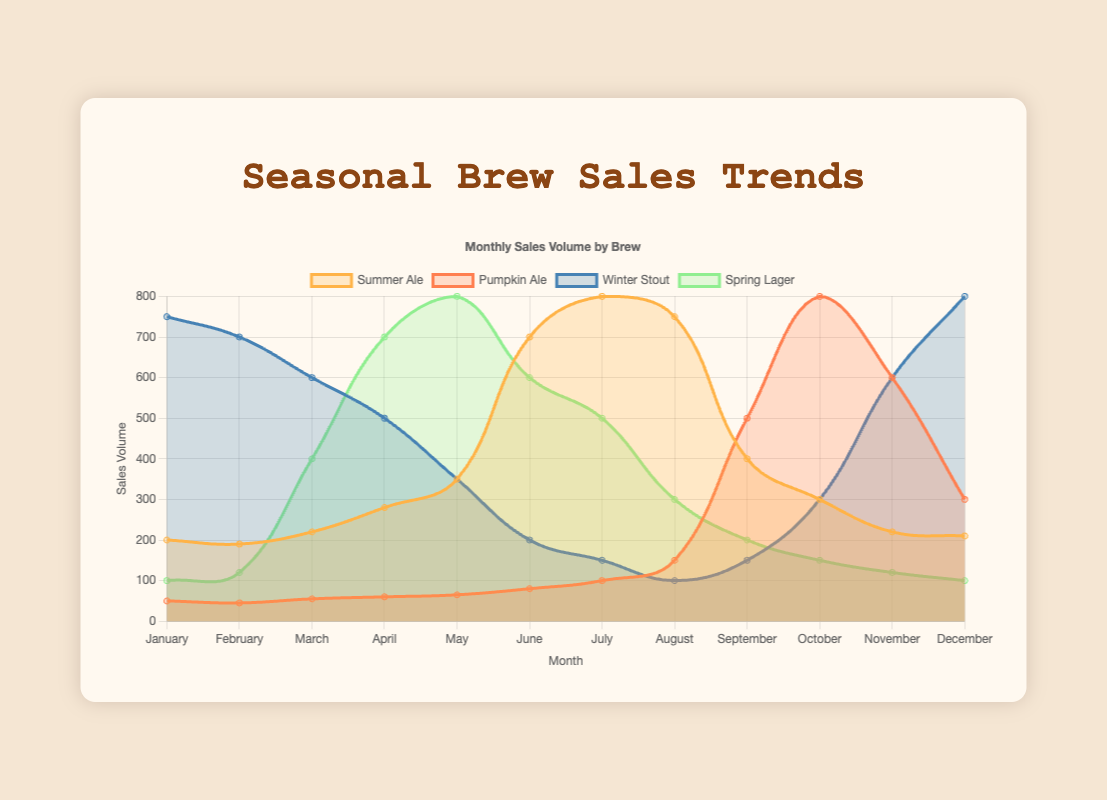What's the peak sale month for Summer Ale? The peak sale month for Summer Ale is identified by the highest point on its sales curve. Observing the plot, July shows the highest sales volume.
Answer: July How do the Winter Stout sales in January compare to the Summer Ale sales in the same month? Compare the heights of the two data points for Winter Stout and Summer Ale in January. Winter Stout has a sales volume of 750, while Summer Ale has a volume of 200. Winter Stout has higher sales.
Answer: Winter Stout has higher sales Which brew experienced the most significant sales drop between consecutive months, and in which months did this occur? To find this, identify the steepest decline in each sales curve. For Spring Lager, the biggest drop is from May to June, decreasing from 800 to 600, giving a difference of 200. For Winter Stout, the drop from January to February is 50, from February to March is 100, and from April to May is 150. For Pumpkin Ale, the drop from October to November is 200. So, the biggest drop is found in Summer Ale in September (750) to October (300), resulting in a 450 decrease.
Answer: Summer Ale, September to October What's the average monthly sales volume for Spring Lager from March to May? Calculate the average by summing the sales volumes for Spring Lager in March (400), April (700), and May (800) and dividing by 3. (400 + 700 + 800) / 3 = 1900 / 3 = 633.33
Answer: 633.33 In which month do Pumpkin Ale and Winter Stout have equal sales volumes? Observe the curve intersection points of Pumpkin Ale and Winter Stout. Both curves intersect at December with the same sales volume of 300.
Answer: December Which month shows the highest overall sales volume across all brews? Sum the sales volumes for all brews in each month, then compare. April totals as Summer Ale (280) + Pumpkin Ale (60) + Winter Stout (500) + Spring Lager (700), resulting in 1540. In July totals, Summer Ale (800) + Pumpkin Ale (100) + Winter Stout (150) + Spring Lager (500), giving a total of 1550.
Answer: July Is there any month where Spring Lager's sales exceed both Summer Ale and Pumpkin Ale? Observe the months where Spring Lager's height exceeds both Summer Ale and Pumpkin Ale in the sales graph. For instance, in April, Spring Lager has 700, Summer Ale has 280, and Pumpkin Ale has 60, so Spring Lager exceeds both.
Answer: April What's the trend of Winter Stout sales from January to December? Winter Stout's curve shows it starts high in January, gradually decreases to the lowest point in August, and then increases again in December.
Answer: Decreases then increases How much higher are Spring Lager's sales in May compared to Pumpkin Ale in the same month? Subtract Pumpkin Ale's sales from Spring Lager in May. Spring Lager is 800, Pumpkin Ale is 65. 800 - 65 = 735
Answer: 735 Which brew has the most stable sales trend throughout the year? Observe the sales graph with the least fluctuation in its curve height. Pumpkin Ale shows consistent lower fluctuations throughout the year compared to others.
Answer: Pumpkin Ale 